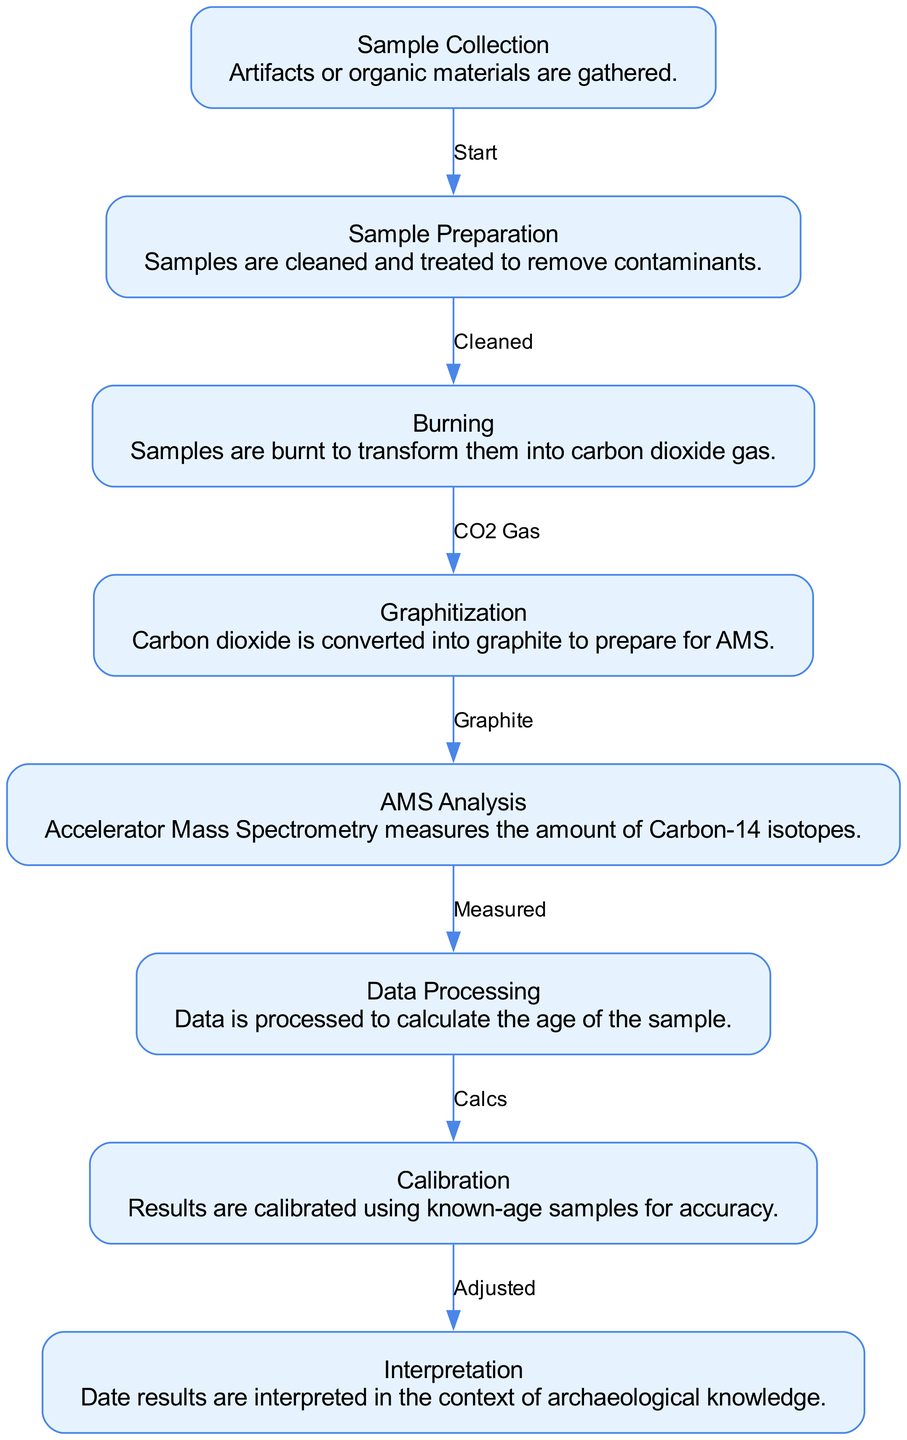What is the first step in the carbon dating process? The diagram indicates that the first step is "Sample Collection" as it is the initial node in the flow of the diagram.
Answer: Sample Collection How many nodes are present in the diagram? By counting the nodes listed in the data section, there are a total of eight nodes representing different steps in the carbon dating process.
Answer: Eight What is the output of the burning step? The burning step produces carbon dioxide gas as indicated by the description linked to the burning node, establishing the product of this particular process step.
Answer: CO2 Gas Which step follows the graphitization process? According to the diagram, the step that follows graphitization is "AMS Analysis," as shown by the directed edge from graphitization to AMS analysis.
Answer: AMS Analysis What is the relationship between sample preparation and burning? The relationship is a directional flow where preparation is completed before moving on to the burning step, indicated by the edge marked as "Cleaned."
Answer: Cleaned Which step includes the use of known-age samples? The calibration step is where known-age samples are used to adjust and ensure the accuracy of the dating results, as described in that node's explanation.
Answer: Calibration What type of data is produced in the AMS Analysis step? The AMS Analysis step produces the measure of Carbon-14 isotopes, as indicated in the description of that node in the diagram.
Answer: Measured How does the process move from data processing to interpretation? The transition from data processing to interpretation occurs after data is calculated and then adjusted during the calibration phase, indicating a process flow that culminates in understanding the results within an archaeological context.
Answer: Adjusted 